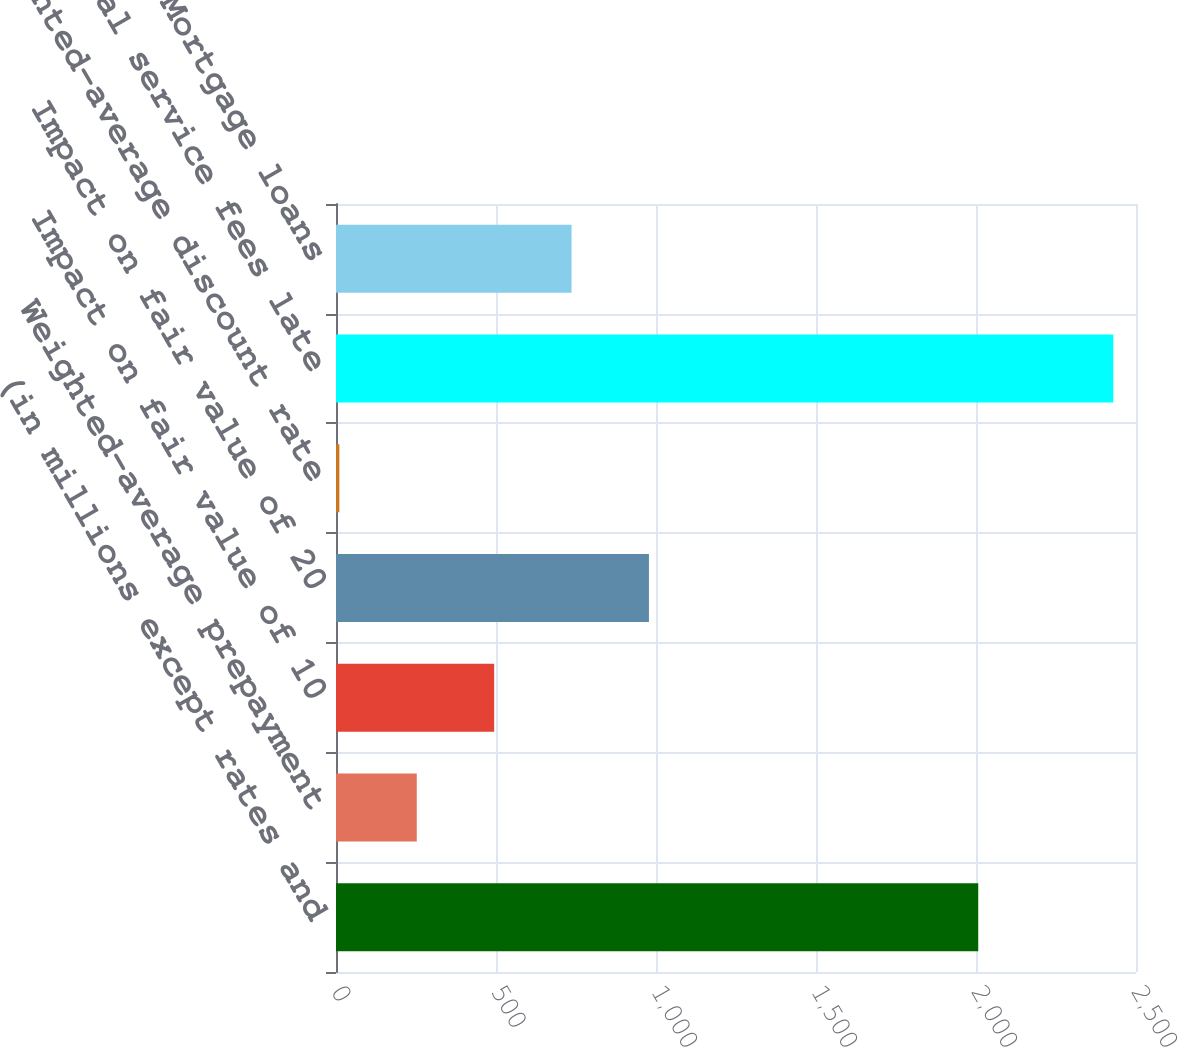Convert chart to OTSL. <chart><loc_0><loc_0><loc_500><loc_500><bar_chart><fcel>(in millions except rates and<fcel>Weighted-average prepayment<fcel>Impact on fair value of 10<fcel>Impact on fair value of 20<fcel>Weighted-average discount rate<fcel>Contractual service fees late<fcel>Third-party Mortgage loans<nl><fcel>2007<fcel>252.38<fcel>494.23<fcel>977.93<fcel>10.53<fcel>2429<fcel>736.08<nl></chart> 